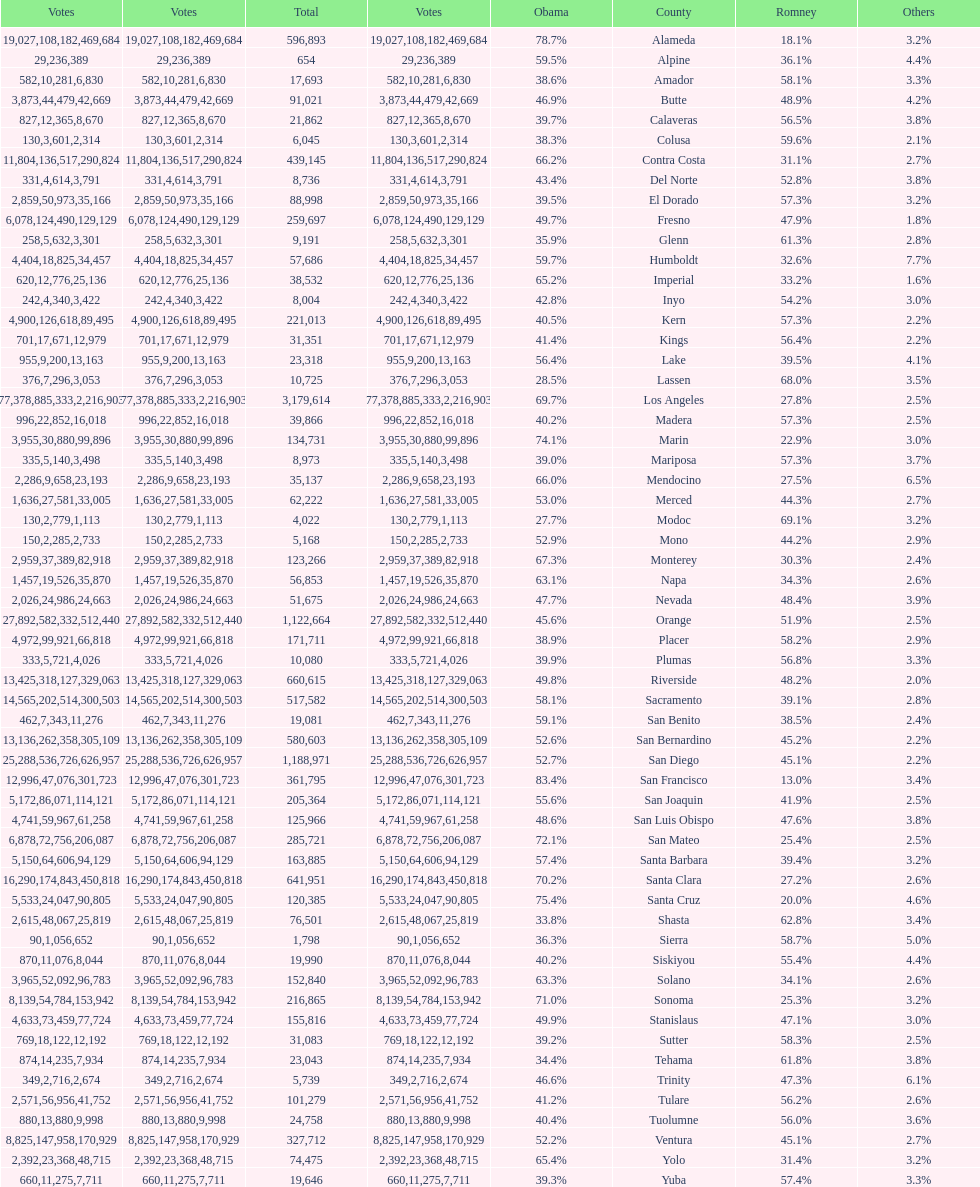What is the number of votes for obama for del norte and el dorado counties? 38957. Parse the full table. {'header': ['Votes', 'Votes', 'Total', 'Votes', 'Obama', 'County', 'Romney', 'Others'], 'rows': [['19,027', '108,182', '596,893', '469,684', '78.7%', 'Alameda', '18.1%', '3.2%'], ['29', '236', '654', '389', '59.5%', 'Alpine', '36.1%', '4.4%'], ['582', '10,281', '17,693', '6,830', '38.6%', 'Amador', '58.1%', '3.3%'], ['3,873', '44,479', '91,021', '42,669', '46.9%', 'Butte', '48.9%', '4.2%'], ['827', '12,365', '21,862', '8,670', '39.7%', 'Calaveras', '56.5%', '3.8%'], ['130', '3,601', '6,045', '2,314', '38.3%', 'Colusa', '59.6%', '2.1%'], ['11,804', '136,517', '439,145', '290,824', '66.2%', 'Contra Costa', '31.1%', '2.7%'], ['331', '4,614', '8,736', '3,791', '43.4%', 'Del Norte', '52.8%', '3.8%'], ['2,859', '50,973', '88,998', '35,166', '39.5%', 'El Dorado', '57.3%', '3.2%'], ['6,078', '124,490', '259,697', '129,129', '49.7%', 'Fresno', '47.9%', '1.8%'], ['258', '5,632', '9,191', '3,301', '35.9%', 'Glenn', '61.3%', '2.8%'], ['4,404', '18,825', '57,686', '34,457', '59.7%', 'Humboldt', '32.6%', '7.7%'], ['620', '12,776', '38,532', '25,136', '65.2%', 'Imperial', '33.2%', '1.6%'], ['242', '4,340', '8,004', '3,422', '42.8%', 'Inyo', '54.2%', '3.0%'], ['4,900', '126,618', '221,013', '89,495', '40.5%', 'Kern', '57.3%', '2.2%'], ['701', '17,671', '31,351', '12,979', '41.4%', 'Kings', '56.4%', '2.2%'], ['955', '9,200', '23,318', '13,163', '56.4%', 'Lake', '39.5%', '4.1%'], ['376', '7,296', '10,725', '3,053', '28.5%', 'Lassen', '68.0%', '3.5%'], ['77,378', '885,333', '3,179,614', '2,216,903', '69.7%', 'Los Angeles', '27.8%', '2.5%'], ['996', '22,852', '39,866', '16,018', '40.2%', 'Madera', '57.3%', '2.5%'], ['3,955', '30,880', '134,731', '99,896', '74.1%', 'Marin', '22.9%', '3.0%'], ['335', '5,140', '8,973', '3,498', '39.0%', 'Mariposa', '57.3%', '3.7%'], ['2,286', '9,658', '35,137', '23,193', '66.0%', 'Mendocino', '27.5%', '6.5%'], ['1,636', '27,581', '62,222', '33,005', '53.0%', 'Merced', '44.3%', '2.7%'], ['130', '2,779', '4,022', '1,113', '27.7%', 'Modoc', '69.1%', '3.2%'], ['150', '2,285', '5,168', '2,733', '52.9%', 'Mono', '44.2%', '2.9%'], ['2,959', '37,389', '123,266', '82,918', '67.3%', 'Monterey', '30.3%', '2.4%'], ['1,457', '19,526', '56,853', '35,870', '63.1%', 'Napa', '34.3%', '2.6%'], ['2,026', '24,986', '51,675', '24,663', '47.7%', 'Nevada', '48.4%', '3.9%'], ['27,892', '582,332', '1,122,664', '512,440', '45.6%', 'Orange', '51.9%', '2.5%'], ['4,972', '99,921', '171,711', '66,818', '38.9%', 'Placer', '58.2%', '2.9%'], ['333', '5,721', '10,080', '4,026', '39.9%', 'Plumas', '56.8%', '3.3%'], ['13,425', '318,127', '660,615', '329,063', '49.8%', 'Riverside', '48.2%', '2.0%'], ['14,565', '202,514', '517,582', '300,503', '58.1%', 'Sacramento', '39.1%', '2.8%'], ['462', '7,343', '19,081', '11,276', '59.1%', 'San Benito', '38.5%', '2.4%'], ['13,136', '262,358', '580,603', '305,109', '52.6%', 'San Bernardino', '45.2%', '2.2%'], ['25,288', '536,726', '1,188,971', '626,957', '52.7%', 'San Diego', '45.1%', '2.2%'], ['12,996', '47,076', '361,795', '301,723', '83.4%', 'San Francisco', '13.0%', '3.4%'], ['5,172', '86,071', '205,364', '114,121', '55.6%', 'San Joaquin', '41.9%', '2.5%'], ['4,741', '59,967', '125,966', '61,258', '48.6%', 'San Luis Obispo', '47.6%', '3.8%'], ['6,878', '72,756', '285,721', '206,087', '72.1%', 'San Mateo', '25.4%', '2.5%'], ['5,150', '64,606', '163,885', '94,129', '57.4%', 'Santa Barbara', '39.4%', '3.2%'], ['16,290', '174,843', '641,951', '450,818', '70.2%', 'Santa Clara', '27.2%', '2.6%'], ['5,533', '24,047', '120,385', '90,805', '75.4%', 'Santa Cruz', '20.0%', '4.6%'], ['2,615', '48,067', '76,501', '25,819', '33.8%', 'Shasta', '62.8%', '3.4%'], ['90', '1,056', '1,798', '652', '36.3%', 'Sierra', '58.7%', '5.0%'], ['870', '11,076', '19,990', '8,044', '40.2%', 'Siskiyou', '55.4%', '4.4%'], ['3,965', '52,092', '152,840', '96,783', '63.3%', 'Solano', '34.1%', '2.6%'], ['8,139', '54,784', '216,865', '153,942', '71.0%', 'Sonoma', '25.3%', '3.2%'], ['4,633', '73,459', '155,816', '77,724', '49.9%', 'Stanislaus', '47.1%', '3.0%'], ['769', '18,122', '31,083', '12,192', '39.2%', 'Sutter', '58.3%', '2.5%'], ['874', '14,235', '23,043', '7,934', '34.4%', 'Tehama', '61.8%', '3.8%'], ['349', '2,716', '5,739', '2,674', '46.6%', 'Trinity', '47.3%', '6.1%'], ['2,571', '56,956', '101,279', '41,752', '41.2%', 'Tulare', '56.2%', '2.6%'], ['880', '13,880', '24,758', '9,998', '40.4%', 'Tuolumne', '56.0%', '3.6%'], ['8,825', '147,958', '327,712', '170,929', '52.2%', 'Ventura', '45.1%', '2.7%'], ['2,392', '23,368', '74,475', '48,715', '65.4%', 'Yolo', '31.4%', '3.2%'], ['660', '11,275', '19,646', '7,711', '39.3%', 'Yuba', '57.4%', '3.3%']]} 